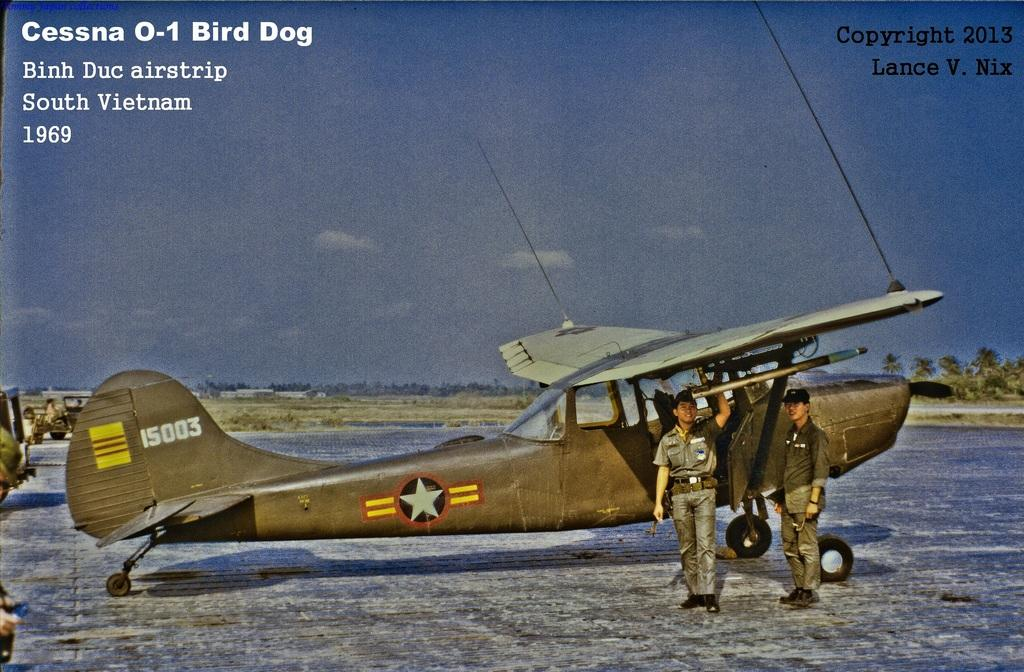<image>
Give a short and clear explanation of the subsequent image. A picture of an airplane in South Vietnam from 1969 